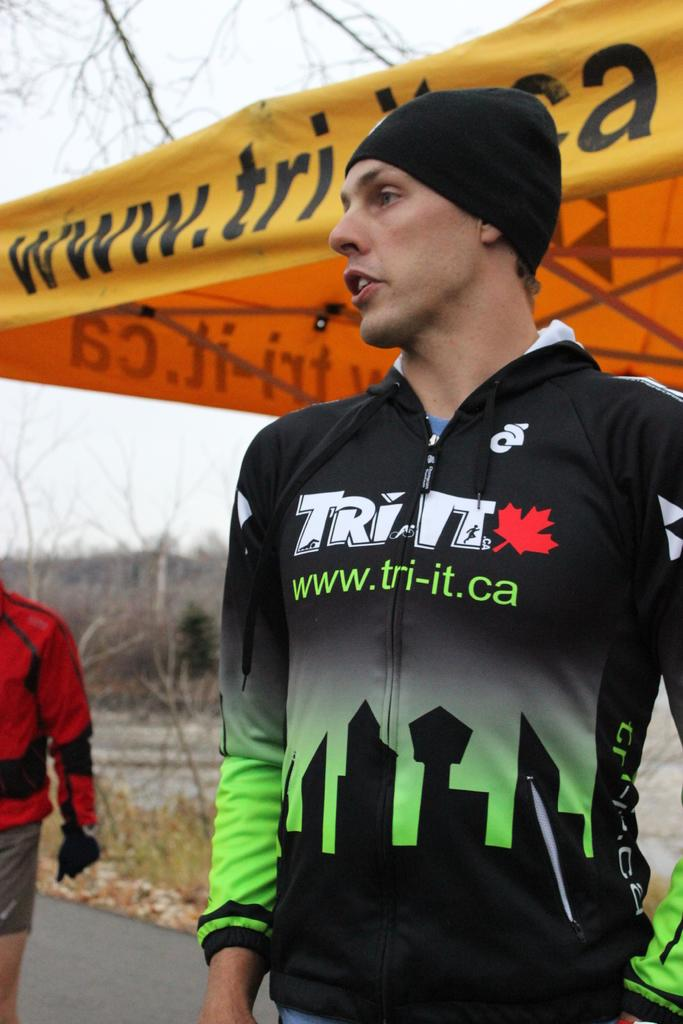<image>
Present a compact description of the photo's key features. A man wears a hoodie with s sky line and www.tri-it.ca on it. 